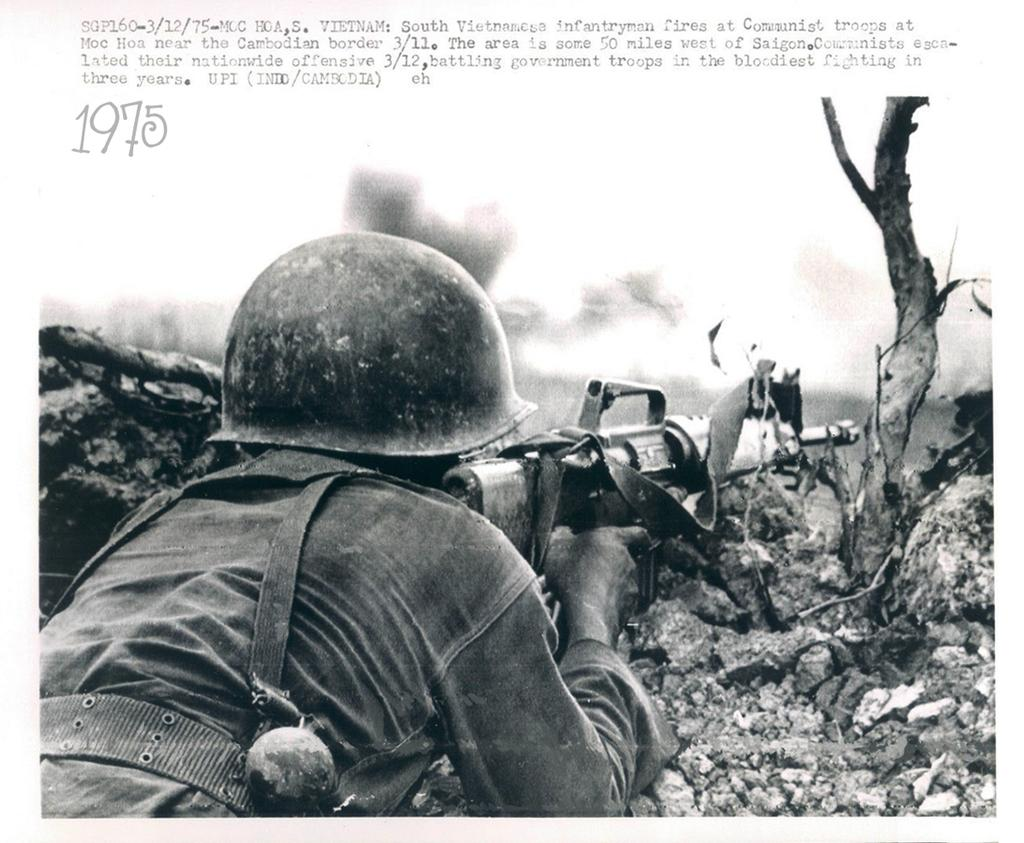What is the man in the image doing? The man is laying on the ground in the image. What is the man holding in his hand? The man is holding a gun in his hand. What type of protective gear is the man wearing? The man is wearing a helmet. What natural element can be seen in the image? There is a tree visible in the image. What else is present in the image besides the man and the tree? There is text present on the image. Can you see a mountain in the background of the image? There is no mountain visible in the image. How does the man walk while laying on the ground in the image? The man is not walking in the image; he is laying on the ground. 